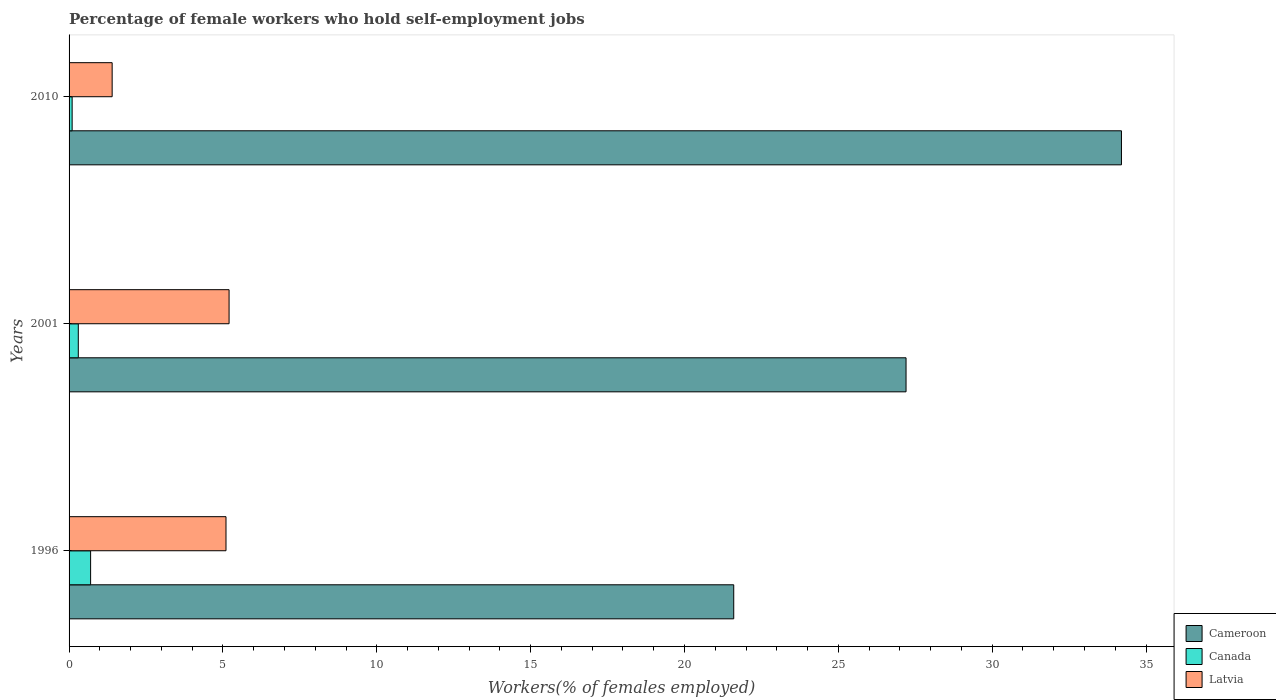How many groups of bars are there?
Give a very brief answer. 3. Are the number of bars per tick equal to the number of legend labels?
Offer a terse response. Yes. How many bars are there on the 3rd tick from the top?
Provide a short and direct response. 3. What is the label of the 2nd group of bars from the top?
Your answer should be compact. 2001. In how many cases, is the number of bars for a given year not equal to the number of legend labels?
Provide a short and direct response. 0. What is the percentage of self-employed female workers in Canada in 1996?
Offer a terse response. 0.7. Across all years, what is the maximum percentage of self-employed female workers in Latvia?
Offer a terse response. 5.2. Across all years, what is the minimum percentage of self-employed female workers in Cameroon?
Your answer should be very brief. 21.6. In which year was the percentage of self-employed female workers in Latvia maximum?
Provide a short and direct response. 2001. What is the total percentage of self-employed female workers in Canada in the graph?
Provide a short and direct response. 1.1. What is the difference between the percentage of self-employed female workers in Cameroon in 1996 and that in 2010?
Offer a very short reply. -12.6. What is the difference between the percentage of self-employed female workers in Cameroon in 2010 and the percentage of self-employed female workers in Canada in 2001?
Offer a terse response. 33.9. What is the average percentage of self-employed female workers in Cameroon per year?
Your answer should be very brief. 27.67. In the year 2001, what is the difference between the percentage of self-employed female workers in Canada and percentage of self-employed female workers in Latvia?
Your answer should be very brief. -4.9. What is the ratio of the percentage of self-employed female workers in Canada in 1996 to that in 2001?
Keep it short and to the point. 2.33. Is the percentage of self-employed female workers in Latvia in 1996 less than that in 2010?
Offer a very short reply. No. What is the difference between the highest and the second highest percentage of self-employed female workers in Latvia?
Make the answer very short. 0.1. What is the difference between the highest and the lowest percentage of self-employed female workers in Latvia?
Offer a terse response. 3.8. In how many years, is the percentage of self-employed female workers in Latvia greater than the average percentage of self-employed female workers in Latvia taken over all years?
Provide a short and direct response. 2. Is the sum of the percentage of self-employed female workers in Latvia in 1996 and 2010 greater than the maximum percentage of self-employed female workers in Canada across all years?
Give a very brief answer. Yes. What does the 2nd bar from the top in 2001 represents?
Your answer should be very brief. Canada. What does the 2nd bar from the bottom in 2001 represents?
Provide a succinct answer. Canada. How many bars are there?
Provide a succinct answer. 9. Are all the bars in the graph horizontal?
Your answer should be compact. Yes. Where does the legend appear in the graph?
Provide a short and direct response. Bottom right. How many legend labels are there?
Offer a terse response. 3. How are the legend labels stacked?
Offer a very short reply. Vertical. What is the title of the graph?
Your answer should be compact. Percentage of female workers who hold self-employment jobs. Does "Libya" appear as one of the legend labels in the graph?
Offer a terse response. No. What is the label or title of the X-axis?
Your answer should be compact. Workers(% of females employed). What is the Workers(% of females employed) of Cameroon in 1996?
Give a very brief answer. 21.6. What is the Workers(% of females employed) in Canada in 1996?
Your answer should be compact. 0.7. What is the Workers(% of females employed) in Latvia in 1996?
Your answer should be compact. 5.1. What is the Workers(% of females employed) of Cameroon in 2001?
Provide a short and direct response. 27.2. What is the Workers(% of females employed) in Canada in 2001?
Your answer should be compact. 0.3. What is the Workers(% of females employed) of Latvia in 2001?
Your response must be concise. 5.2. What is the Workers(% of females employed) in Cameroon in 2010?
Keep it short and to the point. 34.2. What is the Workers(% of females employed) of Canada in 2010?
Provide a short and direct response. 0.1. What is the Workers(% of females employed) in Latvia in 2010?
Offer a very short reply. 1.4. Across all years, what is the maximum Workers(% of females employed) in Cameroon?
Your answer should be very brief. 34.2. Across all years, what is the maximum Workers(% of females employed) of Canada?
Offer a terse response. 0.7. Across all years, what is the maximum Workers(% of females employed) of Latvia?
Your answer should be very brief. 5.2. Across all years, what is the minimum Workers(% of females employed) of Cameroon?
Provide a succinct answer. 21.6. Across all years, what is the minimum Workers(% of females employed) in Canada?
Provide a succinct answer. 0.1. Across all years, what is the minimum Workers(% of females employed) in Latvia?
Provide a short and direct response. 1.4. What is the total Workers(% of females employed) of Cameroon in the graph?
Your answer should be very brief. 83. What is the total Workers(% of females employed) in Latvia in the graph?
Keep it short and to the point. 11.7. What is the difference between the Workers(% of females employed) of Canada in 1996 and that in 2010?
Provide a succinct answer. 0.6. What is the difference between the Workers(% of females employed) of Canada in 2001 and that in 2010?
Your response must be concise. 0.2. What is the difference between the Workers(% of females employed) of Cameroon in 1996 and the Workers(% of females employed) of Canada in 2001?
Your response must be concise. 21.3. What is the difference between the Workers(% of females employed) in Cameroon in 1996 and the Workers(% of females employed) in Latvia in 2010?
Offer a terse response. 20.2. What is the difference between the Workers(% of females employed) of Cameroon in 2001 and the Workers(% of females employed) of Canada in 2010?
Make the answer very short. 27.1. What is the difference between the Workers(% of females employed) of Cameroon in 2001 and the Workers(% of females employed) of Latvia in 2010?
Make the answer very short. 25.8. What is the difference between the Workers(% of females employed) in Canada in 2001 and the Workers(% of females employed) in Latvia in 2010?
Keep it short and to the point. -1.1. What is the average Workers(% of females employed) of Cameroon per year?
Your response must be concise. 27.67. What is the average Workers(% of females employed) in Canada per year?
Keep it short and to the point. 0.37. In the year 1996, what is the difference between the Workers(% of females employed) of Cameroon and Workers(% of females employed) of Canada?
Ensure brevity in your answer.  20.9. In the year 1996, what is the difference between the Workers(% of females employed) of Cameroon and Workers(% of females employed) of Latvia?
Provide a succinct answer. 16.5. In the year 2001, what is the difference between the Workers(% of females employed) of Cameroon and Workers(% of females employed) of Canada?
Offer a terse response. 26.9. In the year 2001, what is the difference between the Workers(% of females employed) of Cameroon and Workers(% of females employed) of Latvia?
Your answer should be very brief. 22. In the year 2010, what is the difference between the Workers(% of females employed) in Cameroon and Workers(% of females employed) in Canada?
Offer a very short reply. 34.1. In the year 2010, what is the difference between the Workers(% of females employed) of Cameroon and Workers(% of females employed) of Latvia?
Make the answer very short. 32.8. In the year 2010, what is the difference between the Workers(% of females employed) in Canada and Workers(% of females employed) in Latvia?
Your response must be concise. -1.3. What is the ratio of the Workers(% of females employed) in Cameroon in 1996 to that in 2001?
Your response must be concise. 0.79. What is the ratio of the Workers(% of females employed) in Canada in 1996 to that in 2001?
Your answer should be compact. 2.33. What is the ratio of the Workers(% of females employed) of Latvia in 1996 to that in 2001?
Provide a short and direct response. 0.98. What is the ratio of the Workers(% of females employed) of Cameroon in 1996 to that in 2010?
Provide a succinct answer. 0.63. What is the ratio of the Workers(% of females employed) of Canada in 1996 to that in 2010?
Your answer should be compact. 7. What is the ratio of the Workers(% of females employed) of Latvia in 1996 to that in 2010?
Ensure brevity in your answer.  3.64. What is the ratio of the Workers(% of females employed) of Cameroon in 2001 to that in 2010?
Your answer should be very brief. 0.8. What is the ratio of the Workers(% of females employed) in Latvia in 2001 to that in 2010?
Ensure brevity in your answer.  3.71. What is the difference between the highest and the second highest Workers(% of females employed) of Cameroon?
Give a very brief answer. 7. What is the difference between the highest and the second highest Workers(% of females employed) in Canada?
Offer a terse response. 0.4. What is the difference between the highest and the lowest Workers(% of females employed) of Cameroon?
Provide a succinct answer. 12.6. What is the difference between the highest and the lowest Workers(% of females employed) of Latvia?
Offer a very short reply. 3.8. 